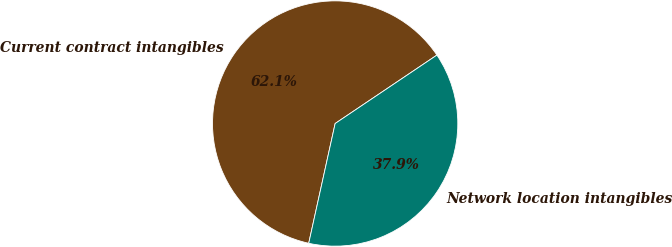<chart> <loc_0><loc_0><loc_500><loc_500><pie_chart><fcel>Current contract intangibles<fcel>Network location intangibles<nl><fcel>62.12%<fcel>37.88%<nl></chart> 